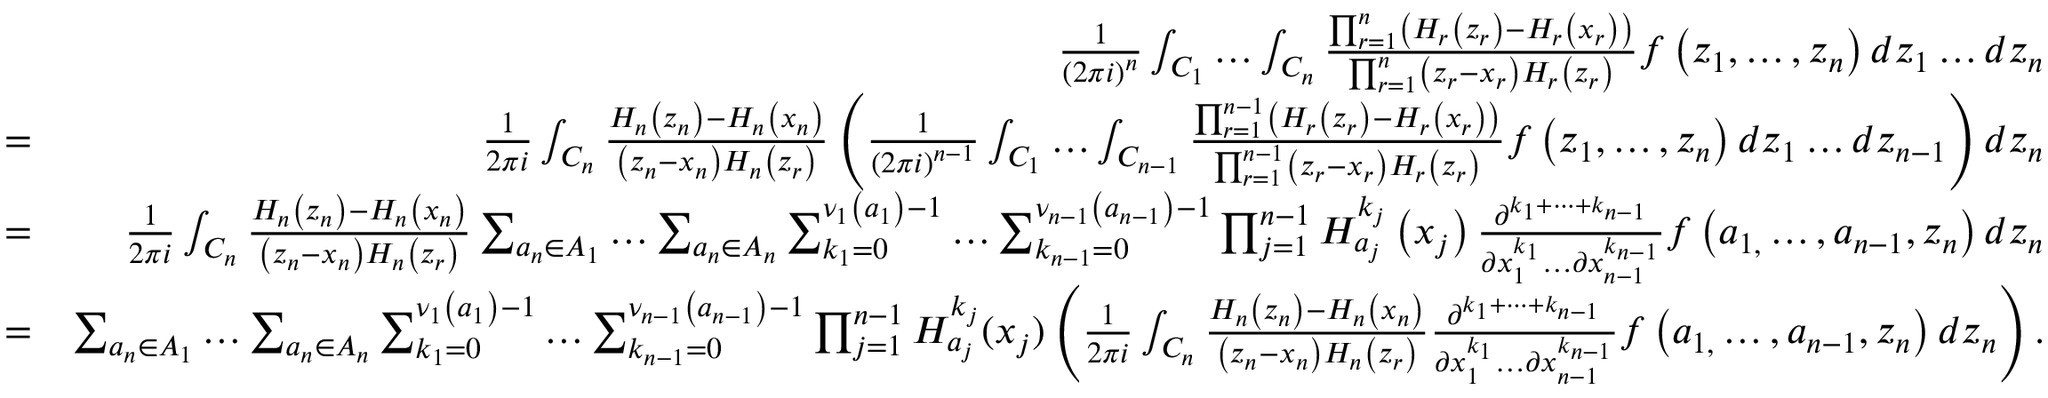Convert formula to latex. <formula><loc_0><loc_0><loc_500><loc_500>\begin{array} { r l r } & { \frac { 1 } { \left ( 2 \pi i \right ) ^ { n } } \int _ { C _ { 1 } } \dots \int _ { C _ { n } } \frac { \prod _ { r = 1 } ^ { n } \left ( H _ { r } \left ( z _ { r } \right ) - H _ { r } \left ( x _ { r } \right ) \right ) } { \prod _ { r = 1 } ^ { n } \left ( z _ { r } - x _ { r } \right ) H _ { r } \left ( z _ { r } \right ) } f \left ( z _ { 1 } , \dots , z _ { n } \right ) d z _ { 1 } \dots d z _ { n } } \\ & { = } & { \frac { 1 } { 2 \pi i } \int _ { C _ { n } } \frac { H _ { n } \left ( z _ { n } \right ) - H _ { n } \left ( x _ { n } \right ) } { \left ( z _ { n } - x _ { n } \right ) H _ { n } \left ( z _ { r } \right ) } \left ( \frac { 1 } { \left ( 2 \pi i \right ) ^ { n - 1 } } \int _ { C _ { 1 } } \dots \int _ { C _ { n - 1 } } \frac { \prod _ { r = 1 } ^ { n - 1 } \left ( H _ { r } \left ( z _ { r } \right ) - H _ { r } \left ( x _ { r } \right ) \right ) } { \prod _ { r = 1 } ^ { n - 1 } \left ( z _ { r } - x _ { r } \right ) H _ { r } \left ( z _ { r } \right ) } f \left ( z _ { 1 } , \dots , z _ { n } \right ) d z _ { 1 } \dots d z _ { n - 1 } \right ) d z _ { n } } \\ & { = } & { \frac { 1 } { 2 \pi i } \int _ { C _ { n } } \frac { H _ { n } \left ( z _ { n } \right ) - H _ { n } \left ( x _ { n } \right ) } { \left ( z _ { n } - x _ { n } \right ) H _ { n } \left ( z _ { r } \right ) } \sum _ { a _ { n } \in A _ { 1 } } \dots \sum _ { a _ { n } \in A _ { n } } \sum _ { k _ { 1 } = 0 } ^ { \nu _ { 1 } \left ( a _ { 1 } \right ) - 1 } \dots \sum _ { k _ { n - 1 } = 0 } ^ { \nu _ { n - 1 } \left ( a _ { n - 1 } \right ) - 1 } \prod _ { j = 1 } ^ { n - 1 } H _ { a _ { j } } ^ { k _ { j } } \left ( x _ { j } \right ) \frac { \partial ^ { { k } _ { 1 } + \dots + k _ { n - 1 } } } { \partial x _ { 1 } ^ { k _ { 1 } } \dots \partial x _ { n - 1 } ^ { k _ { n - 1 } } } f \left ( a _ { 1 , } \dots , a _ { n - 1 } , z _ { n } \right ) d z _ { n } } \\ & { = } & { \sum _ { a _ { n } \in A _ { 1 } } \dots \sum _ { a _ { n } \in A _ { n } } \sum _ { k _ { 1 } = 0 } ^ { \nu _ { 1 } \left ( a _ { 1 } \right ) - 1 } \dots \sum _ { k _ { n - 1 } = 0 } ^ { \nu _ { n - 1 } \left ( a _ { n - 1 } \right ) - 1 } \prod _ { j = 1 } ^ { n - 1 } H _ { a _ { j } } ^ { k _ { j } } ( x _ { j } ) \left ( \frac { 1 } { 2 \pi i } \int _ { C _ { n } } \frac { H _ { n } \left ( z _ { n } \right ) - H _ { n } \left ( x _ { n } \right ) } { \left ( z _ { n } - x _ { n } \right ) H _ { n } \left ( z _ { r } \right ) } \frac { \partial ^ { { k } _ { 1 } + \dots + k _ { n - 1 } } } { \partial x _ { 1 } ^ { k _ { 1 } } \dots \partial x _ { n - 1 } ^ { k _ { n - 1 } } } f \left ( a _ { 1 , } \dots , a _ { n - 1 } , z _ { n } \right ) d z _ { n } \right ) . } \end{array}</formula> 